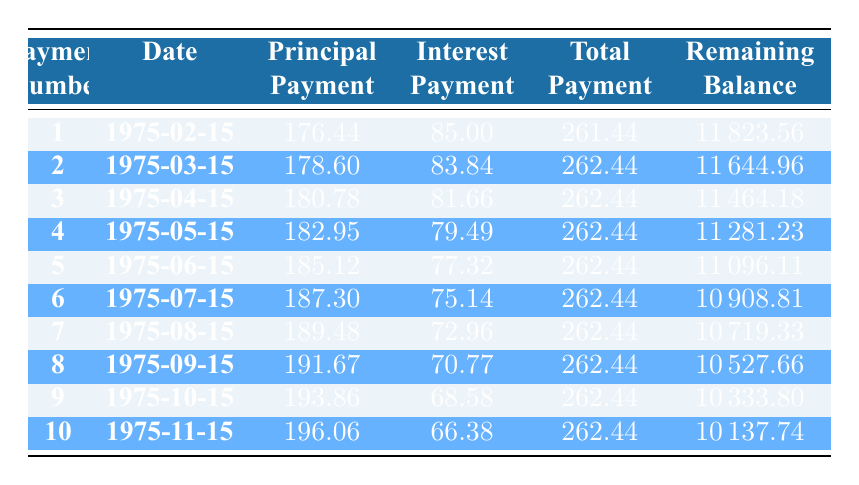What was the principal payment in the first month? The first month's principal payment is listed directly in the table under the Principal Payment column for Payment Number 1, which is 176.44.
Answer: 176.44 What is the total payment made in the third month? Looking at the table, the third month's total payment can be found in the Total Payment column for Payment Number 3, which is 262.44.
Answer: 262.44 Was the interest payment in the sixth month higher than the interest payment in the fifth month? The interest payment for the sixth month is 75.14, while for the fifth month it is 77.32. Since 75.14 is less than 77.32, the answer is no.
Answer: No What is the remaining balance after the fourth payment? The remaining balance after the fourth payment can be found in the Remaining Balance column next to Payment Number 4, which is 11281.23.
Answer: 11281.23 Calculate the average principal payment over the first ten months. To find the average principal payment, we sum the principal payments from Payment Numbers 1 to 10: (176.44 + 178.60 + 180.78 + 182.95 + 185.12 + 187.30 + 189.48 + 191.67 + 193.86 + 196.06 = 1880.23) and then divide by 10, resulting in 1880.23 / 10 = 188.03.
Answer: 188.03 What was the total interest paid in the first three payments? Gathering the interest payments for the first three payments: 85.00 (first) + 83.84 (second) + 81.66 (third) = 250.50. Therefore, the total interest paid in the first three payments is 250.50.
Answer: 250.50 Is the total payment the same for each month? By examining the Total Payment column, we see that for the first ten payments, the total payments are 261.44 in month 1, and 262.44 for months 2 to 10. Thus, the answer is no since the first month's payment differs.
Answer: No What is the difference in principal payment between the first and the last month among the first ten? The principal payment in the first month is 176.44, while in the last (tenth) month it is 196.06. The difference can be calculated as 196.06 - 176.44, which equals 19.62.
Answer: 19.62 What was the remaining balance after the fifth payment? The remaining balance after the fifth payment is found directly in the table under the Remaining Balance column for Payment Number 5, which shows 11096.11.
Answer: 11096.11 